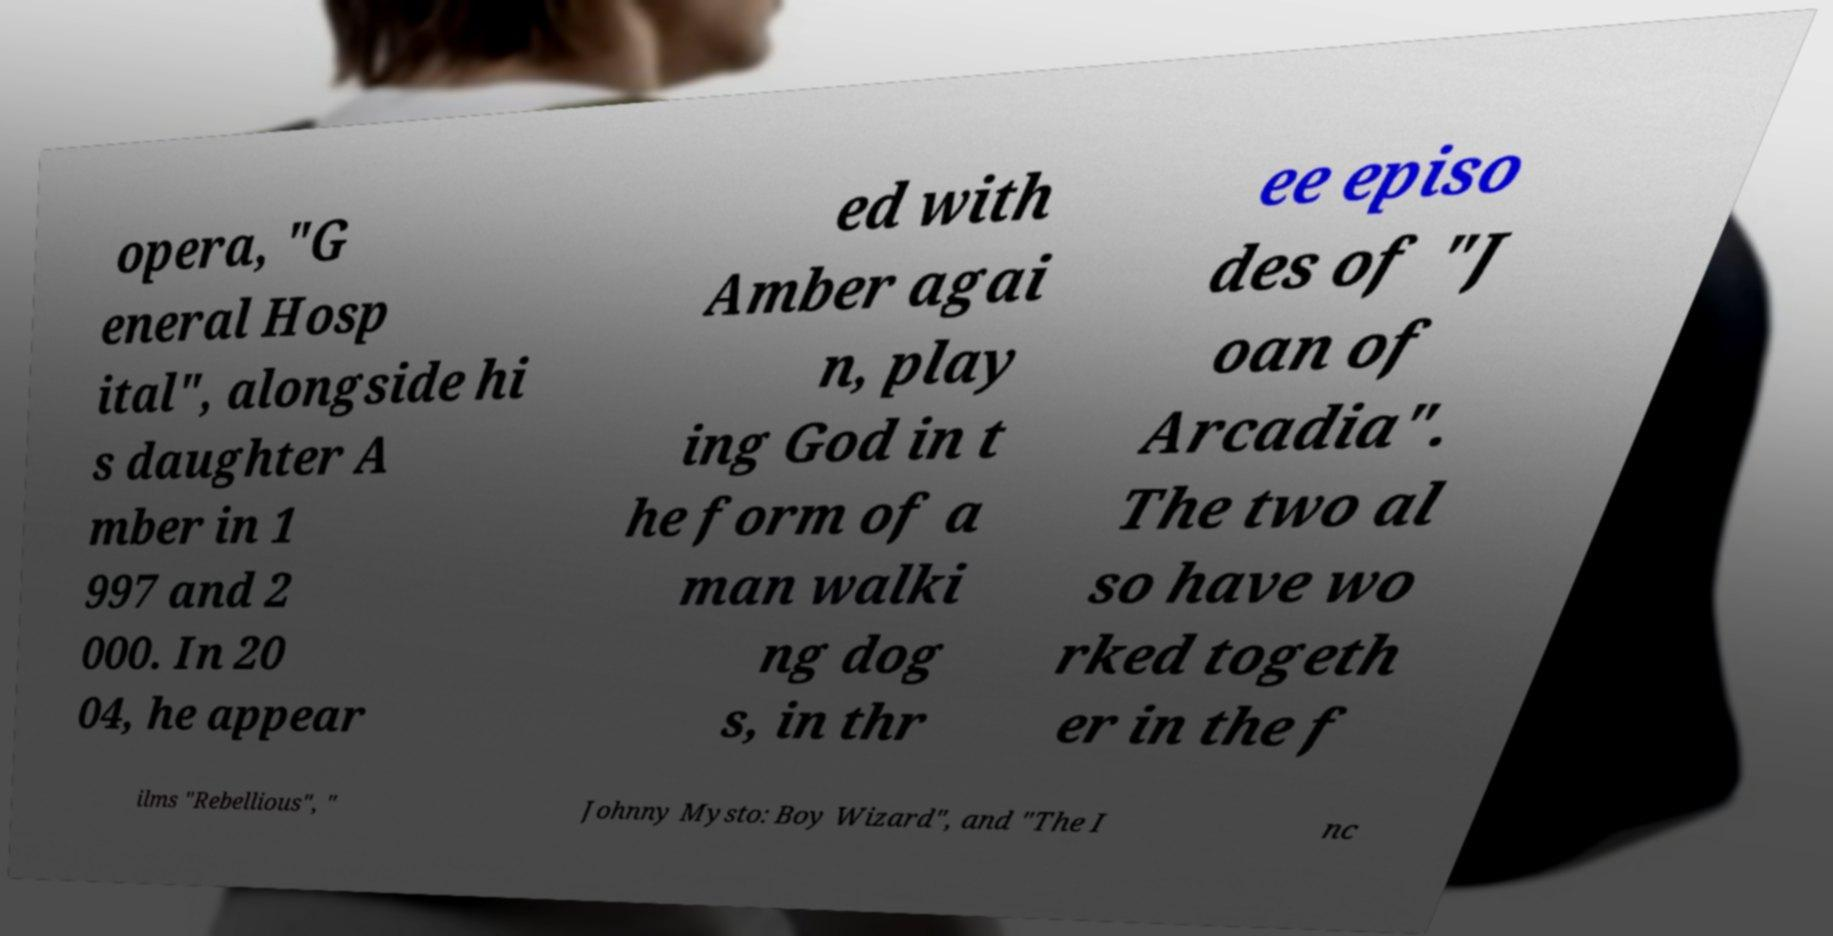Please read and relay the text visible in this image. What does it say? opera, "G eneral Hosp ital", alongside hi s daughter A mber in 1 997 and 2 000. In 20 04, he appear ed with Amber agai n, play ing God in t he form of a man walki ng dog s, in thr ee episo des of "J oan of Arcadia". The two al so have wo rked togeth er in the f ilms "Rebellious", " Johnny Mysto: Boy Wizard", and "The I nc 